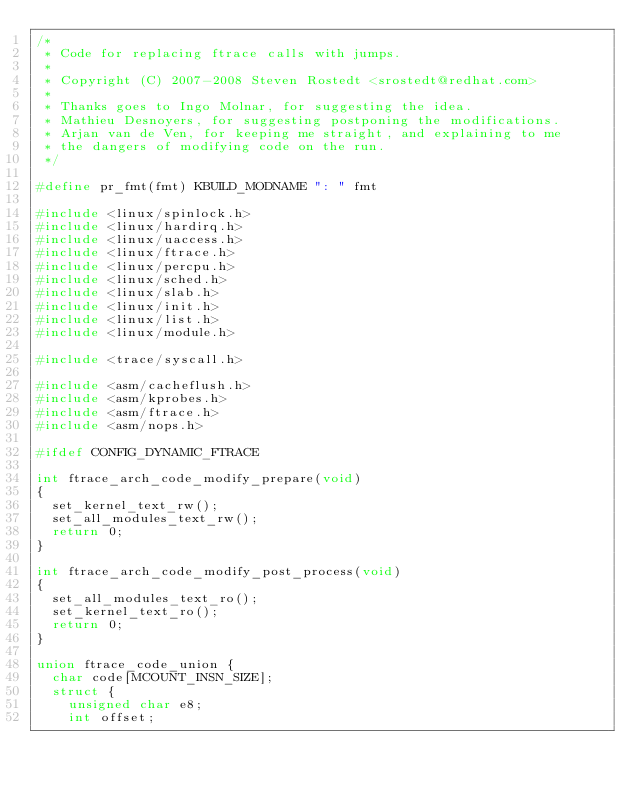<code> <loc_0><loc_0><loc_500><loc_500><_C_>/*
 * Code for replacing ftrace calls with jumps.
 *
 * Copyright (C) 2007-2008 Steven Rostedt <srostedt@redhat.com>
 *
 * Thanks goes to Ingo Molnar, for suggesting the idea.
 * Mathieu Desnoyers, for suggesting postponing the modifications.
 * Arjan van de Ven, for keeping me straight, and explaining to me
 * the dangers of modifying code on the run.
 */

#define pr_fmt(fmt) KBUILD_MODNAME ": " fmt

#include <linux/spinlock.h>
#include <linux/hardirq.h>
#include <linux/uaccess.h>
#include <linux/ftrace.h>
#include <linux/percpu.h>
#include <linux/sched.h>
#include <linux/slab.h>
#include <linux/init.h>
#include <linux/list.h>
#include <linux/module.h>

#include <trace/syscall.h>

#include <asm/cacheflush.h>
#include <asm/kprobes.h>
#include <asm/ftrace.h>
#include <asm/nops.h>

#ifdef CONFIG_DYNAMIC_FTRACE

int ftrace_arch_code_modify_prepare(void)
{
	set_kernel_text_rw();
	set_all_modules_text_rw();
	return 0;
}

int ftrace_arch_code_modify_post_process(void)
{
	set_all_modules_text_ro();
	set_kernel_text_ro();
	return 0;
}

union ftrace_code_union {
	char code[MCOUNT_INSN_SIZE];
	struct {
		unsigned char e8;
		int offset;</code> 